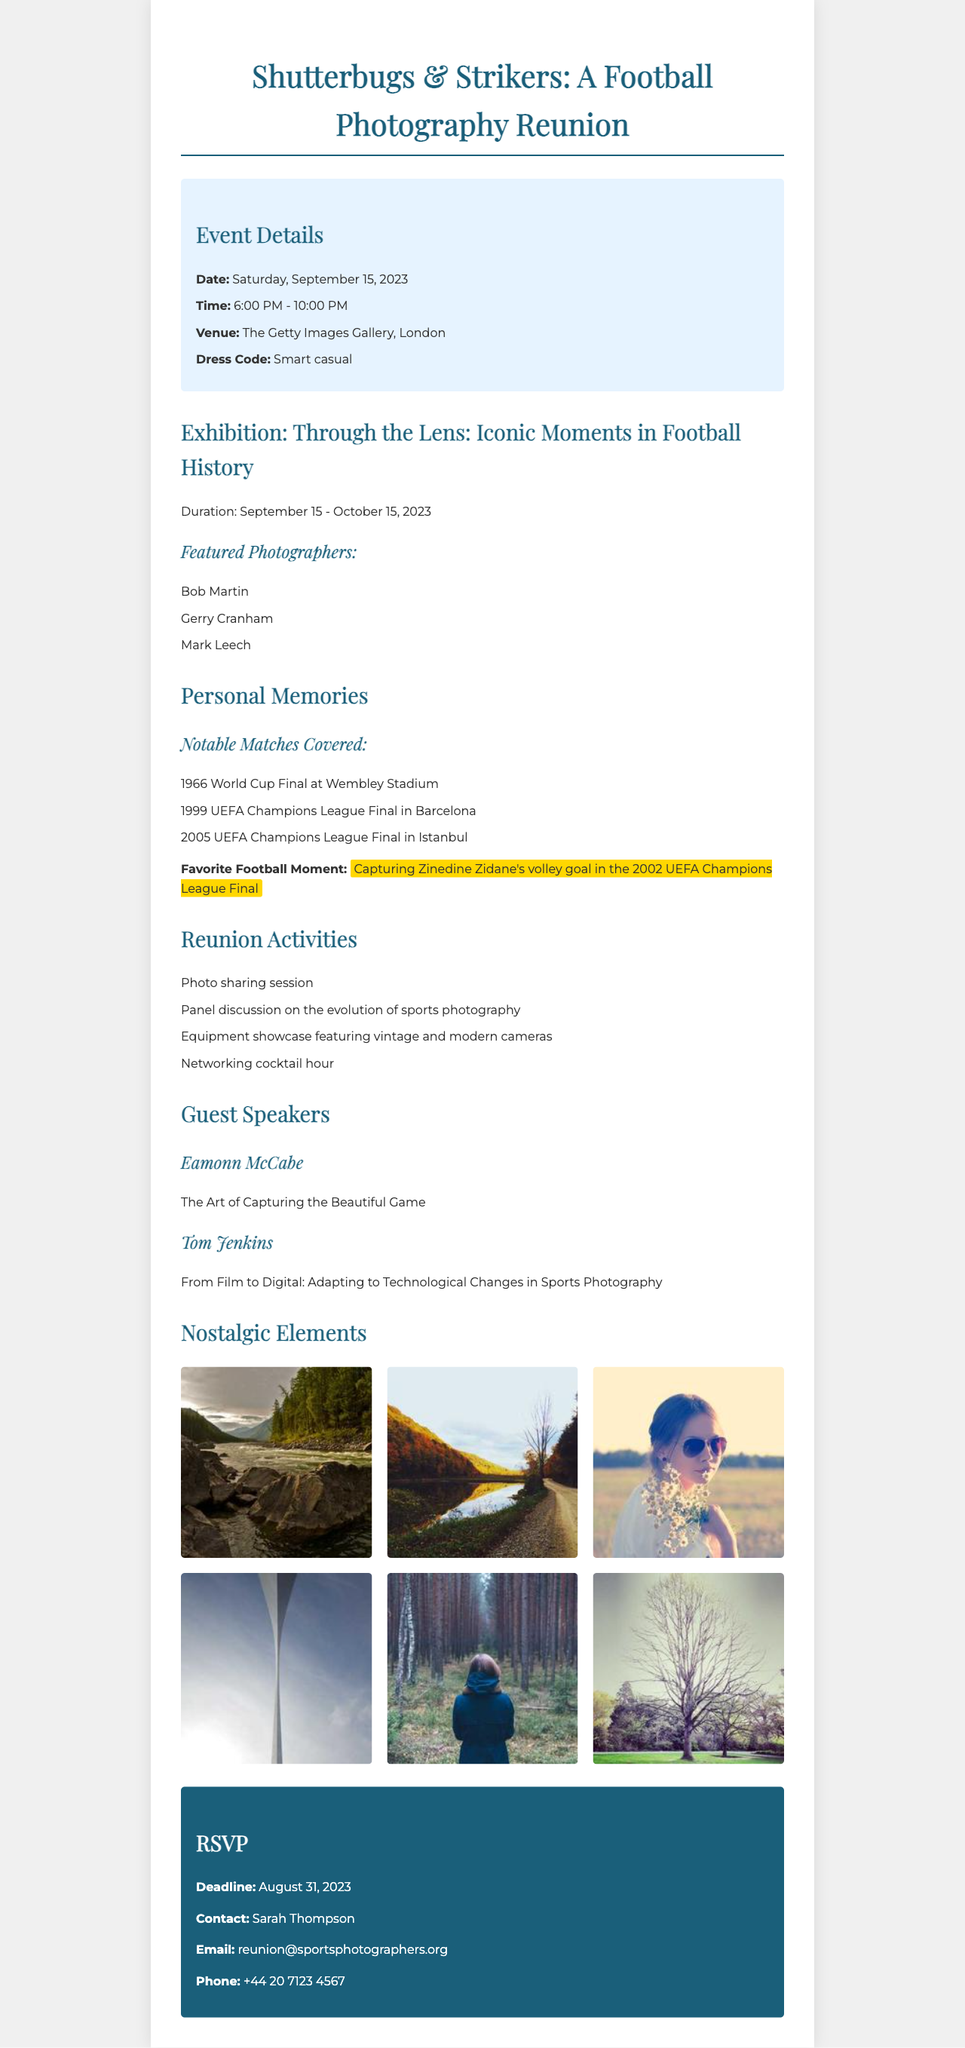What is the name of the event? The event name is clearly stated at the beginning of the document, highlighting the reunion of retired sports photographers.
Answer: Shutterbugs & Strikers: A Football Photography Reunion When is the event scheduled? The date of the event is explicitly mentioned in the document under event details.
Answer: Saturday, September 15, 2023 What is the venue for the reunion? The location where the reunion will take place is specified in the venue section of the document.
Answer: The Getty Images Gallery, London Who is a featured photographer in the exhibition? The document lists several photographers involved in the exhibition, which can be identified by looking at the featured photographers section.
Answer: Bob Martin What is the duration of the exhibition? The exhibition duration is provided in the exhibition information section, indicating how long it will be open to the public.
Answer: September 15 - October 15, 2023 What is the dress code for the event? The dress code for the event is mentioned clearly under the event details to guide attendees on appropriate attire.
Answer: Smart casual What is the favorite football moment shared? The document includes a personal memory regarding a specific football moment that the author cherishes.
Answer: Capturing Zinedine Zidane's volley goal in the 2002 UEFA Champions League Final Who is one of the guest speakers? The document identifies guest speakers and their topics, making it easy to name at least one speaker from that list.
Answer: Eamonn McCabe What activity is included in the reunion? The document outlines several activities planned for the reunion, allowing for the identification of one of them.
Answer: Photo sharing session 